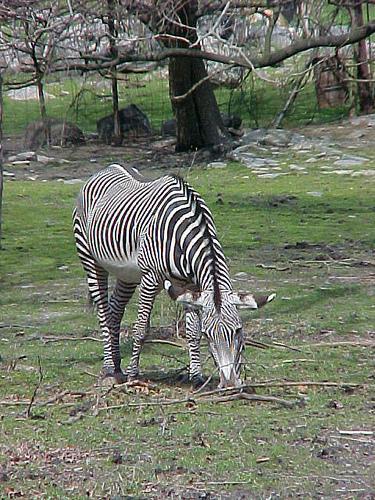How many zebras are there?
Give a very brief answer. 1. 